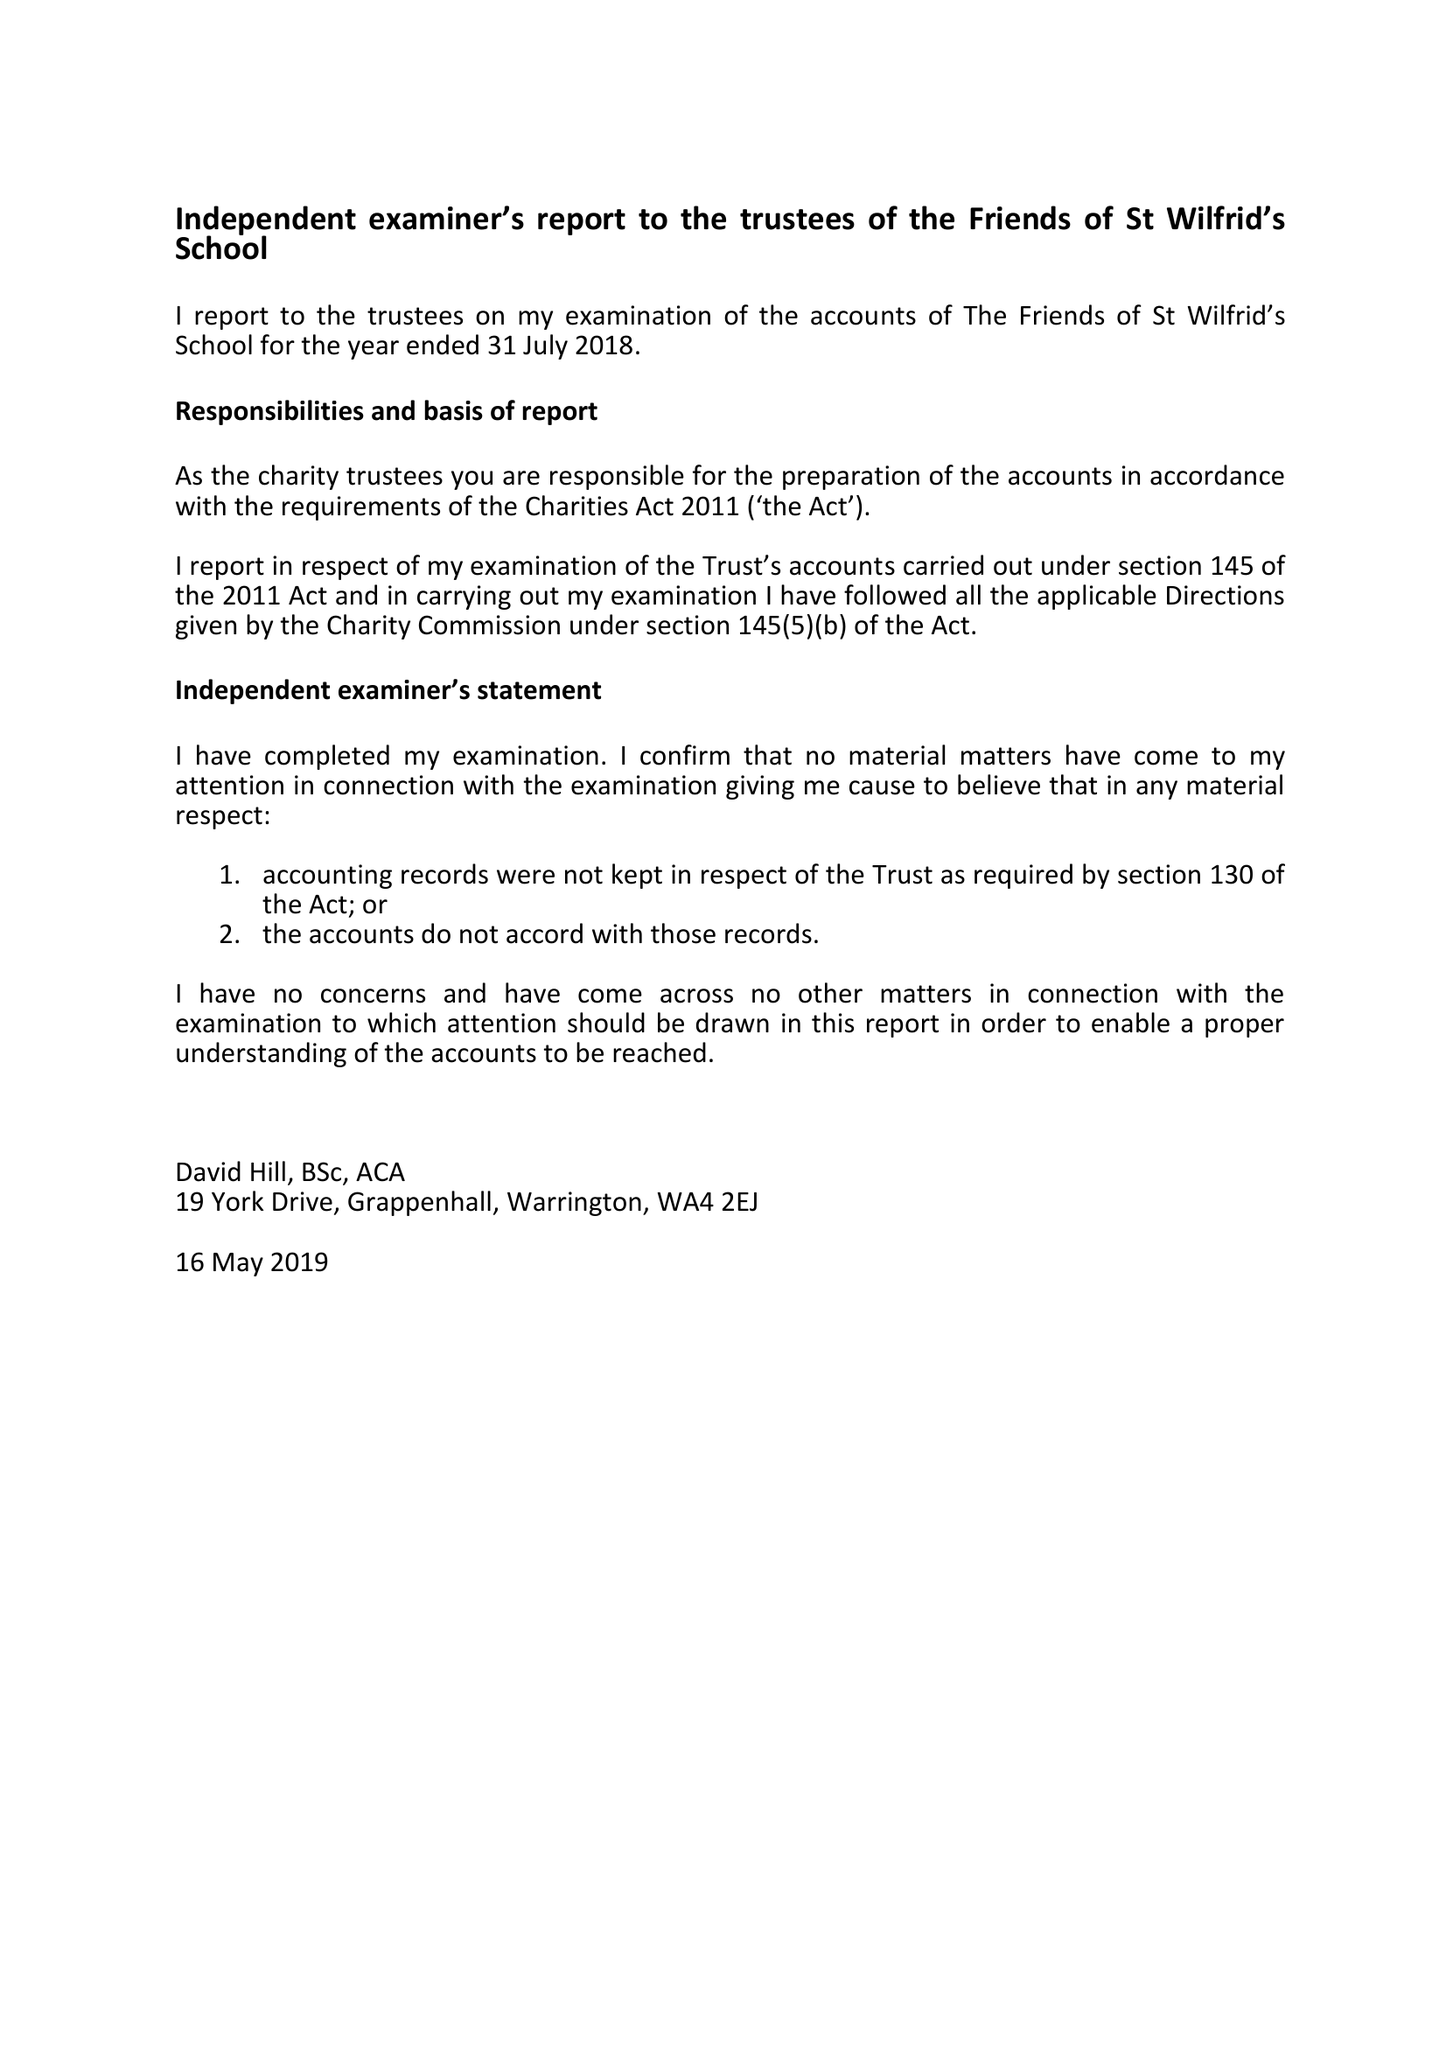What is the value for the charity_name?
Answer the question using a single word or phrase. The Friends Of St Wilfrids School 